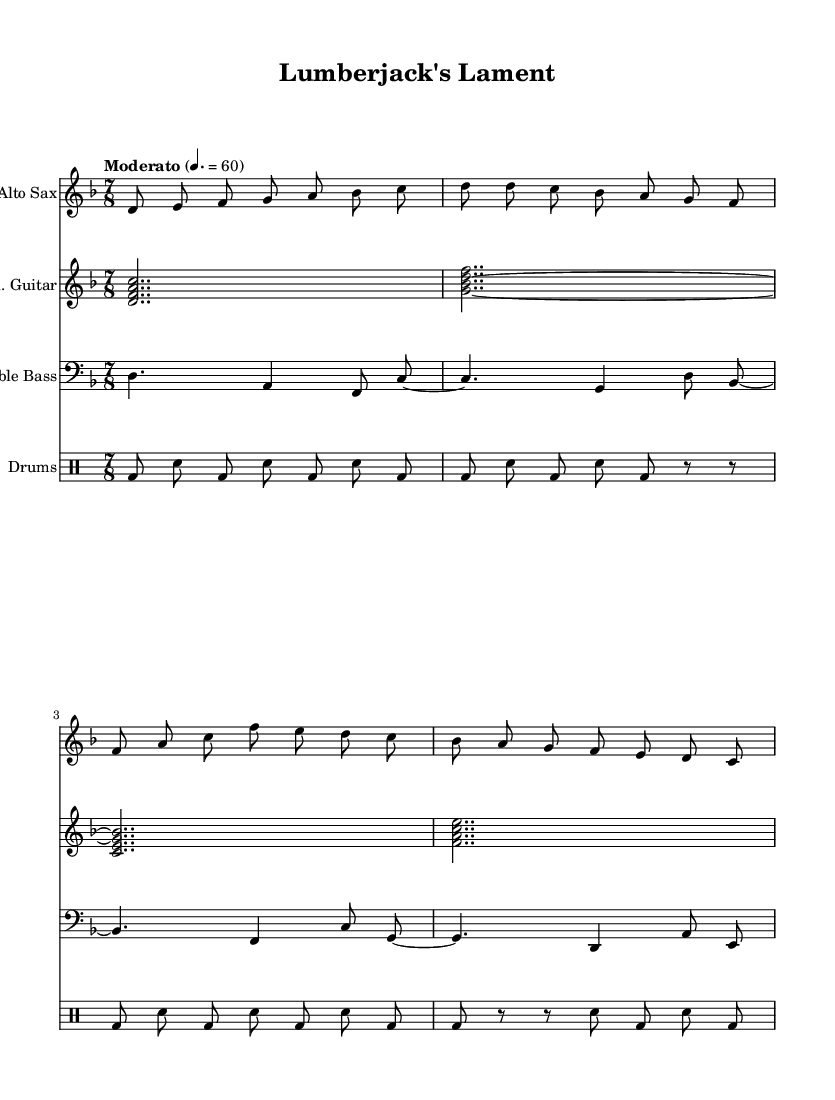What is the key signature of this music? The key signature is indicated at the beginning of the score. It shows two flats, which correspond to the notes B flat and E flat, indicating that the piece is in D minor.
Answer: D minor What is the time signature of this music? The time signature is represented in the first measure of the score. It shows "7/8," which indicates there are seven eighth notes per measure.
Answer: 7/8 What is the tempo marking of this piece? The tempo marking is typically found above the staff. It is written as "Moderato," which indicates a moderate speed, and includes a metronome marking of 60 beats per minute.
Answer: Moderato, 60 How many measures are in the alto sax part? To determine the number of measures, we can count the measures represented in the saxophone staff. In the provided notation, there are four measures present.
Answer: 4 What instruments are involved in this composition? The instruments can be identified by the instrument names listed at the beginning of each staff. The composition includes alto sax, electric guitar, double bass, and drums.
Answer: Alto Sax, Electric Guitar, Double Bass, Drums What rhythmic pattern is used in the drum set? The drum set part shows a rhythmic pattern with a specific sequence of bass drum (bd) and snare (sn) hits over the measures. The pattern consistently alternates between these two drum sounds, creating a driving rhythm.
Answer: Alternating bass drum and snare What is the first note of the electric guitar part? The first note can be found in the first measure of the electric guitar staff. The guitar starts with the note D, which is the lowest note in the chord represented in the first measure.
Answer: D 